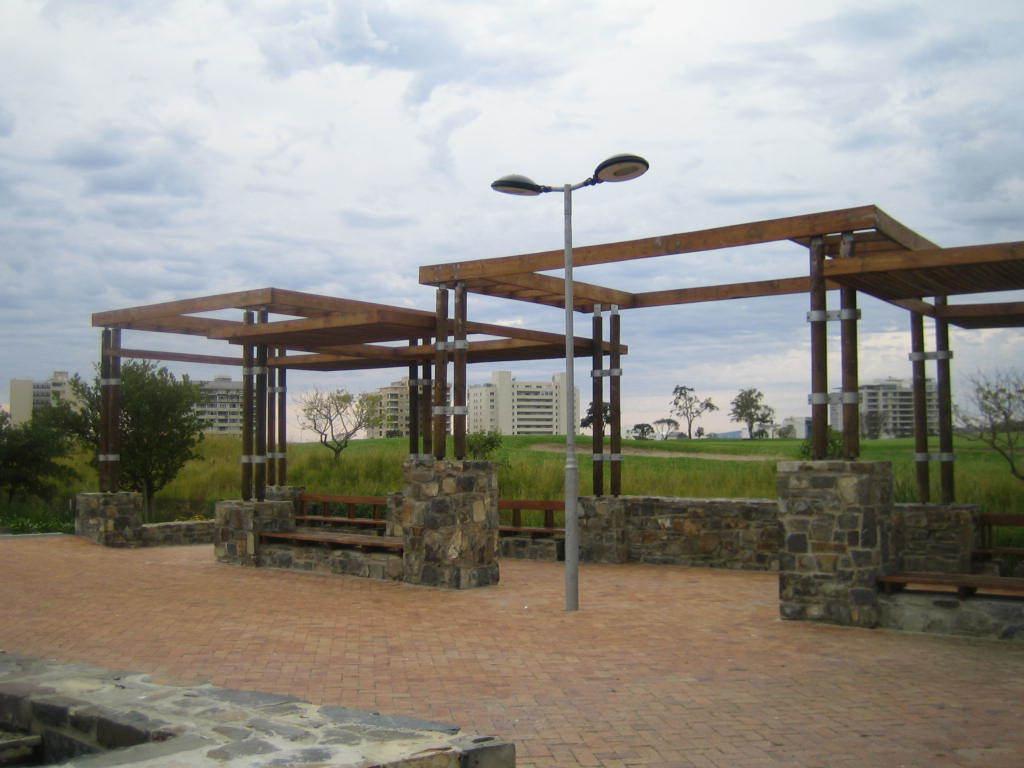Could you give a brief overview of what you see in this image? In this image in the center, there are some wooden poles and street light. At the bottom there is a walkway and in the background there are some houses, trees and grass, on the top of the image there is sky. 